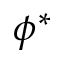<formula> <loc_0><loc_0><loc_500><loc_500>\phi ^ { * }</formula> 